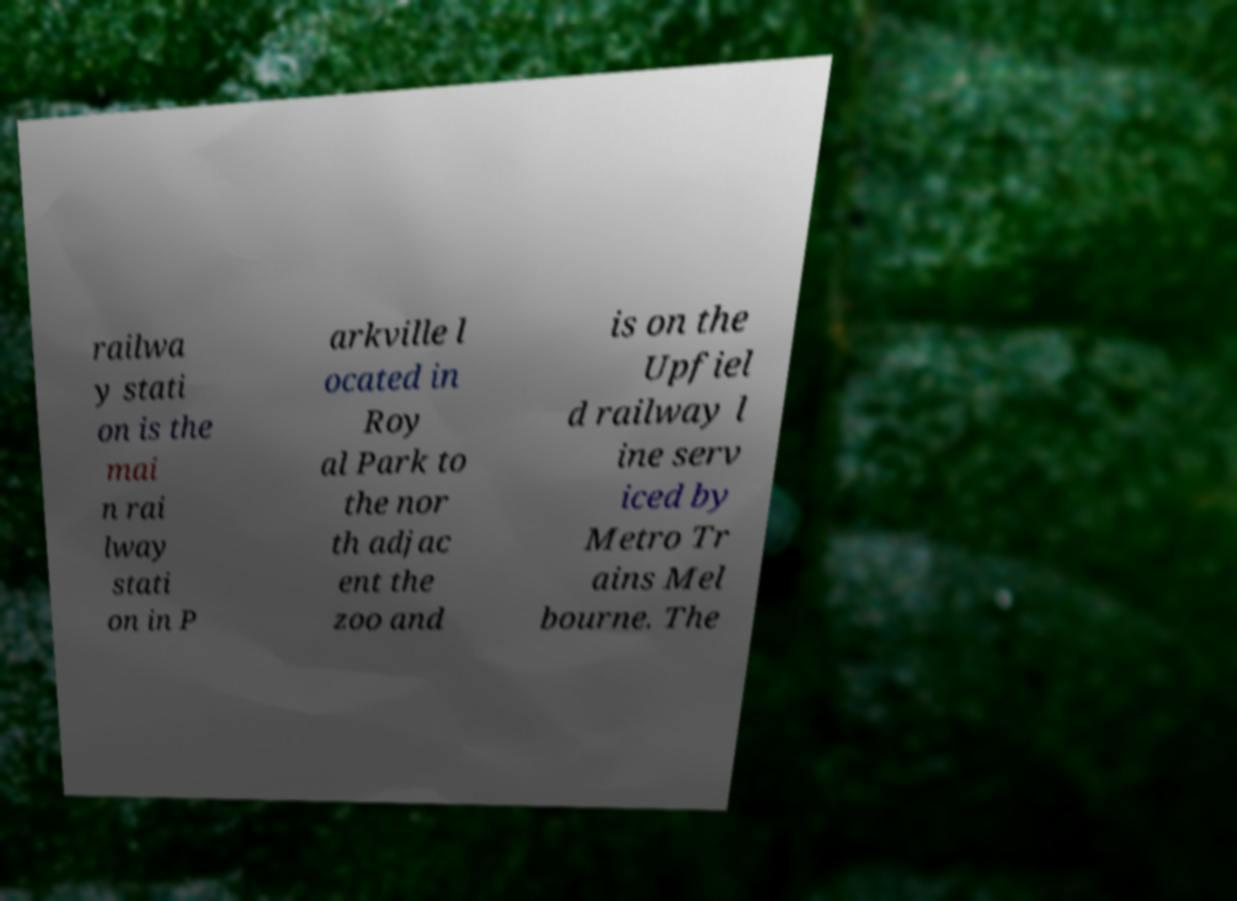Could you extract and type out the text from this image? railwa y stati on is the mai n rai lway stati on in P arkville l ocated in Roy al Park to the nor th adjac ent the zoo and is on the Upfiel d railway l ine serv iced by Metro Tr ains Mel bourne. The 